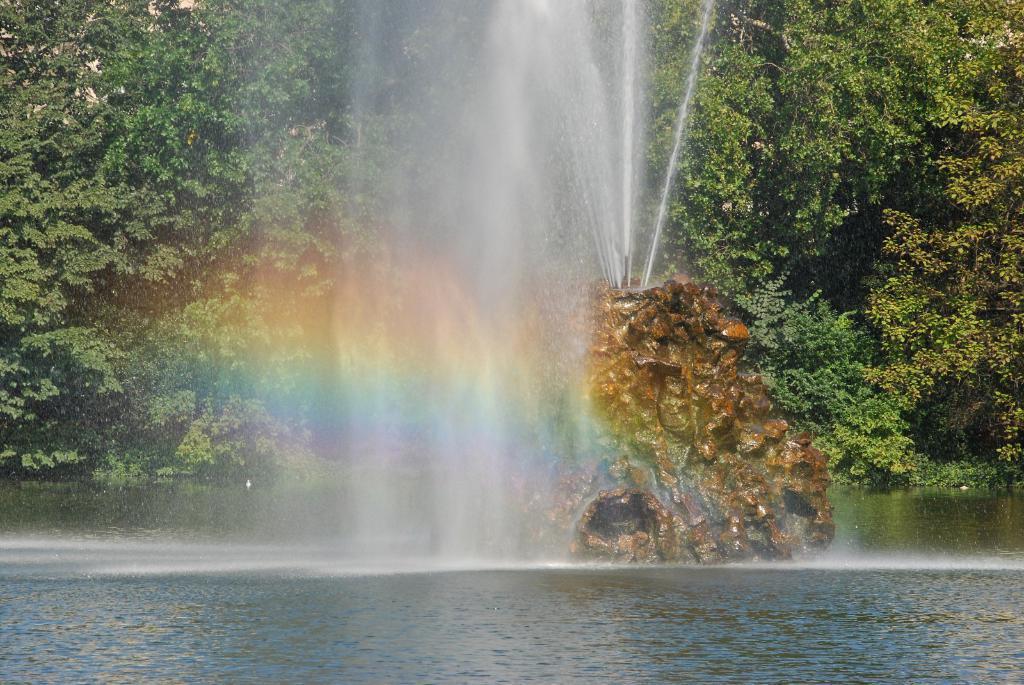Please provide a concise description of this image. In this image I see the trees, fountain on this stone and I see the rainbow over here and I can also see the water. 